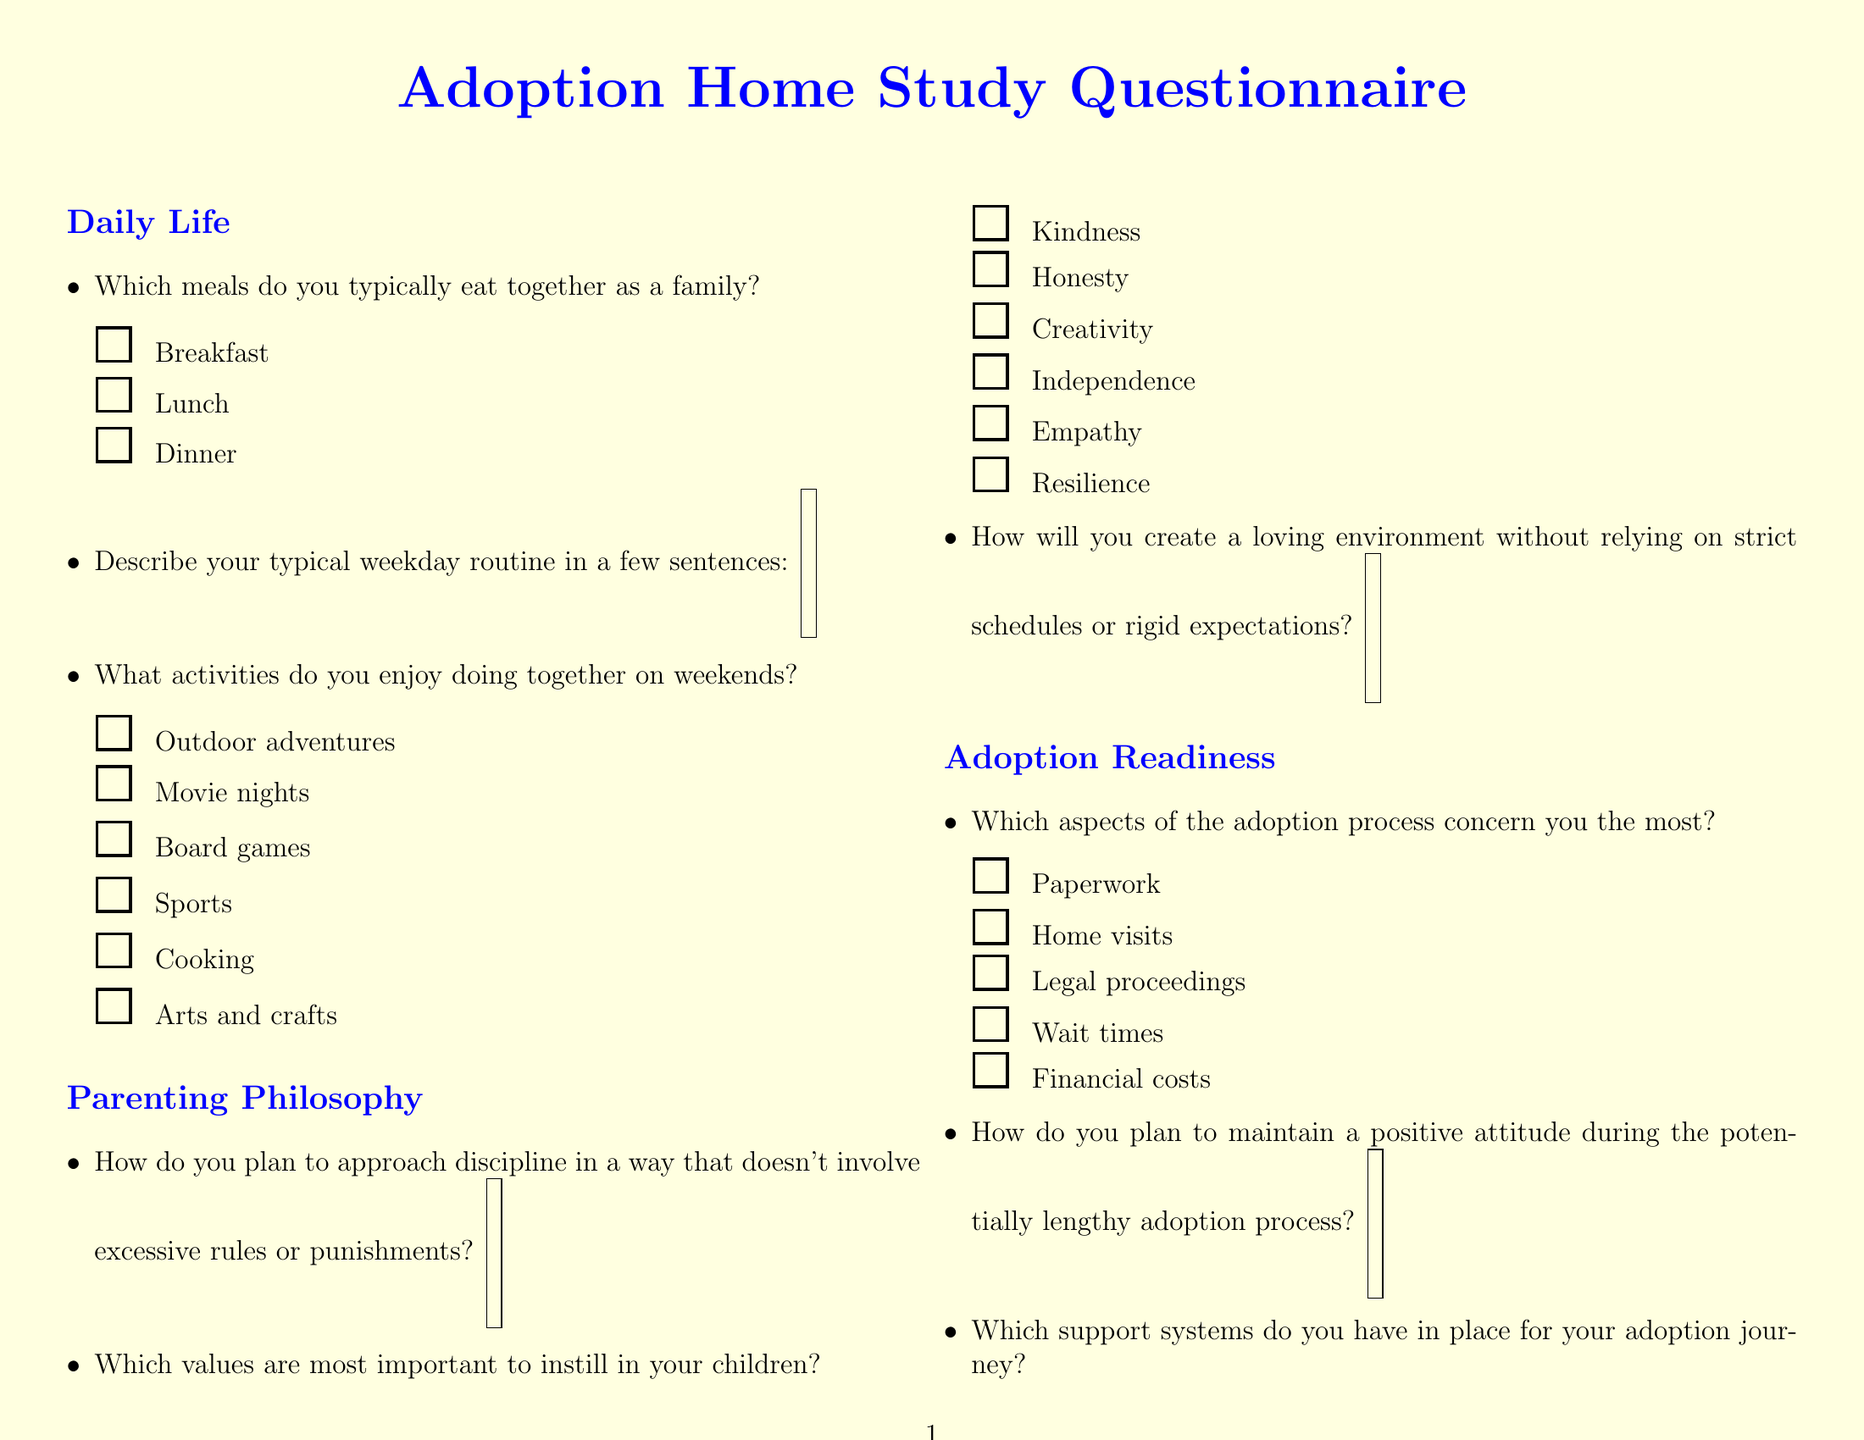Which meals are listed for family meals? The document includes a checkbox question listing the meals the family typically eats together.
Answer: Breakfast, Lunch, Dinner What are common weekend activities noted in the document? The question regarding weekend activities includes various options that families might enjoy together.
Answer: Outdoor adventures, Movie nights, Board games, Sports, Cooking, Arts and crafts Which values are suggested for instilling in children? The document specifies a checkbox question where certain values are highlighted as important to instill in children.
Answer: Kindness, Honesty, Creativity, Independence, Empathy, Resilience What concerns about the adoption process are mentioned? The document notes specific aspects of the adoption process that may be concerning, and these are listed in a checkbox question.
Answer: Paperwork, Home visits, Legal proceedings, Wait times, Financial costs How many sections are included in the adoption questionnaire? By counting the sections delineated in the document, we can find out how many areas the questionnaire covers.
Answer: 5 What support systems are mentioned for the adoption journey? The question on support systems includes options for what resources one may have available during the adoption process.
Answer: Family, Friends, Adoption support groups, Therapist, Faith community What neighborhood characteristics are listed in the form? The document contains a question that asks about the characteristics of a person's neighborhood, which are check boxed.
Answer: Family-friendly, Close to parks, Good schools nearby, Safe for outdoor play, Diverse community What are the resources mentioned for learning about transracial adoption? A checkbox question in the document lists various resources that one can utilize to learn more about transracial adoption.
Answer: Books, Online forums, Cultural events, Adoptee blogs, Adoption agencies How does the document suggest celebrating the child's cultural heritage? The document contains a question that prompts the respondent to describe their plan for celebrating the adopted child's cultural background without it feeling forced.
Answer: Short answer response expected 